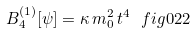Convert formula to latex. <formula><loc_0><loc_0><loc_500><loc_500>B _ { 4 } ^ { ( 1 ) } [ \psi ] = \kappa \, m _ { 0 } ^ { 2 } \, t ^ { 4 } \ f i g { 0 2 2 }</formula> 